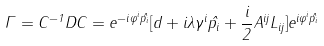Convert formula to latex. <formula><loc_0><loc_0><loc_500><loc_500>\Gamma = C ^ { - 1 } D C = e ^ { - i \varphi ^ { i } \hat { p _ { i } } } [ d + i \lambda \gamma ^ { i } \hat { p _ { i } } + \frac { i } { 2 } A ^ { i j } L _ { i j } ] e ^ { i \varphi ^ { i } \hat { p _ { i } } }</formula> 